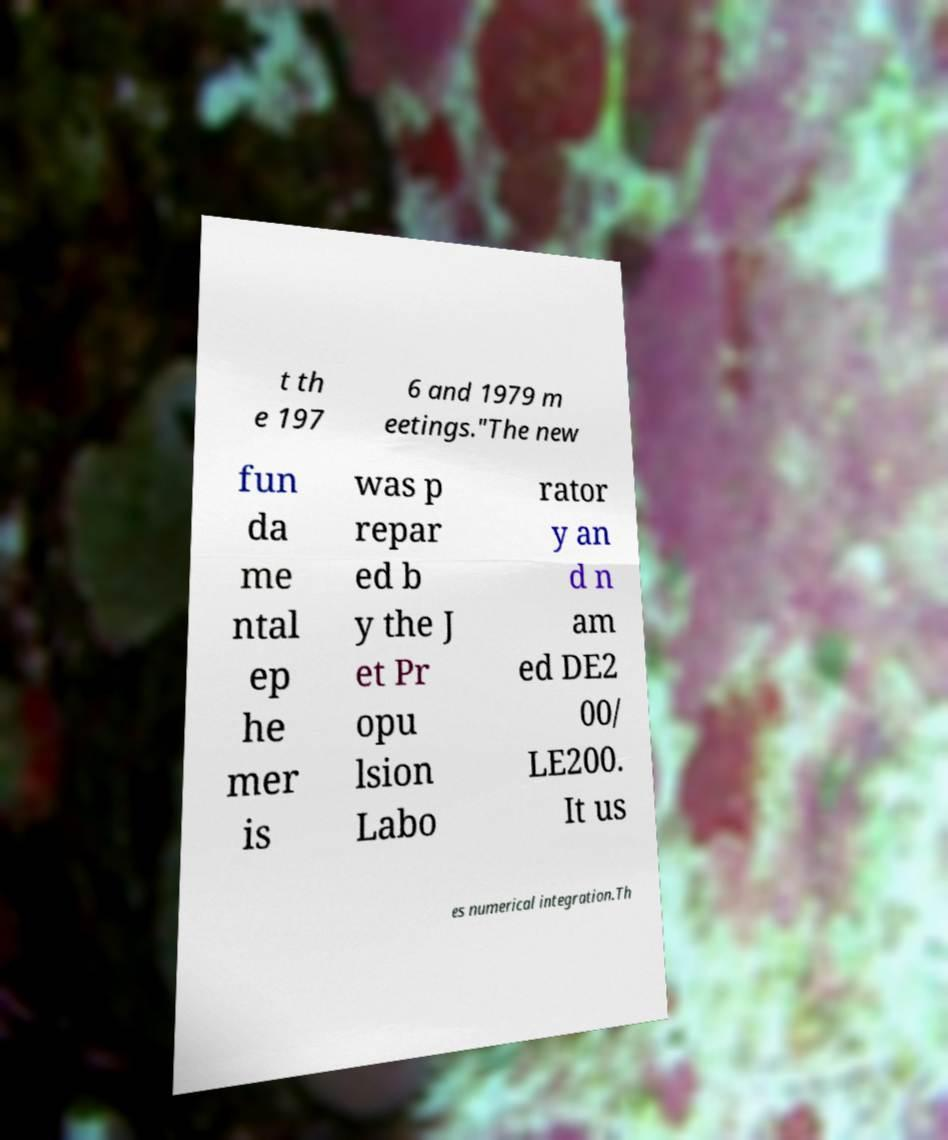What messages or text are displayed in this image? I need them in a readable, typed format. t th e 197 6 and 1979 m eetings."The new fun da me ntal ep he mer is was p repar ed b y the J et Pr opu lsion Labo rator y an d n am ed DE2 00/ LE200. It us es numerical integration.Th 